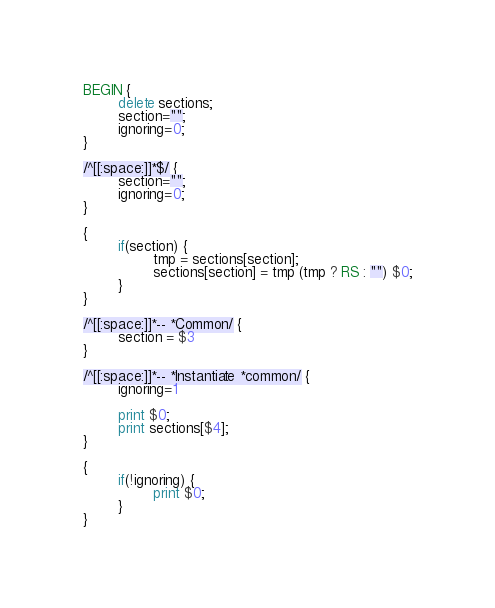Convert code to text. <code><loc_0><loc_0><loc_500><loc_500><_Awk_>BEGIN {
        delete sections;
        section="";
        ignoring=0;
}

/^[[:space:]]*$/ {
        section="";
        ignoring=0;
}

{
        if(section) {
                tmp = sections[section];
                sections[section] = tmp (tmp ? RS : "") $0;
        }
}

/^[[:space:]]*-- *Common/ {
        section = $3
}

/^[[:space:]]*-- *Instantiate *common/ {
        ignoring=1

        print $0;
        print sections[$4];
}

{
        if(!ignoring) {
                print $0;
        }
}
</code> 